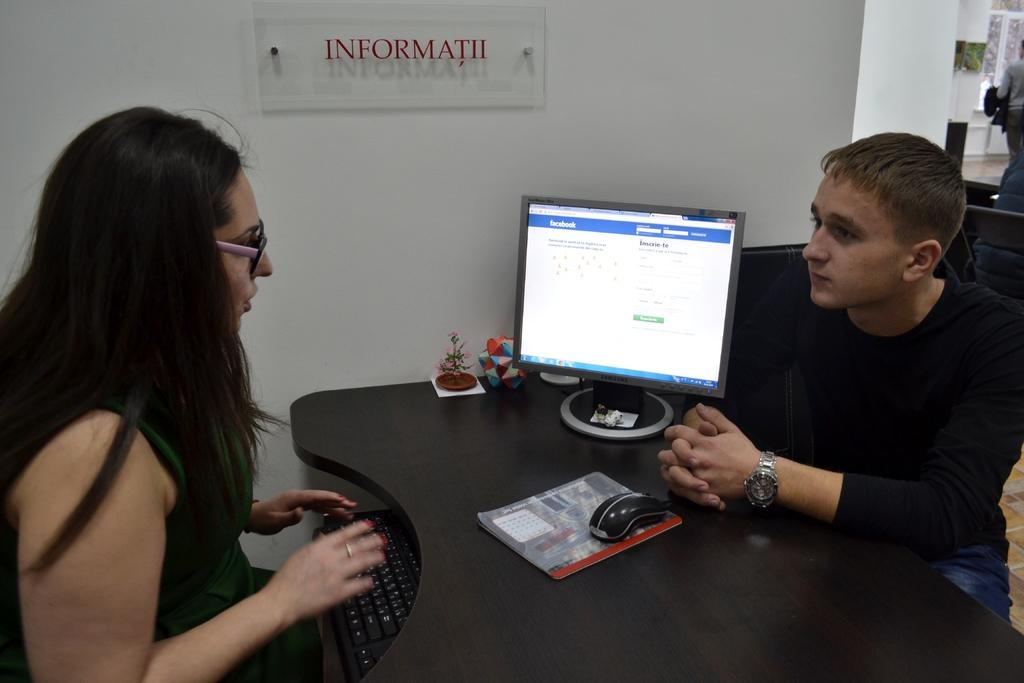<image>
Write a terse but informative summary of the picture. A young man speaks to a woman at a desk while a screen displaying Facebook is on the screen. 